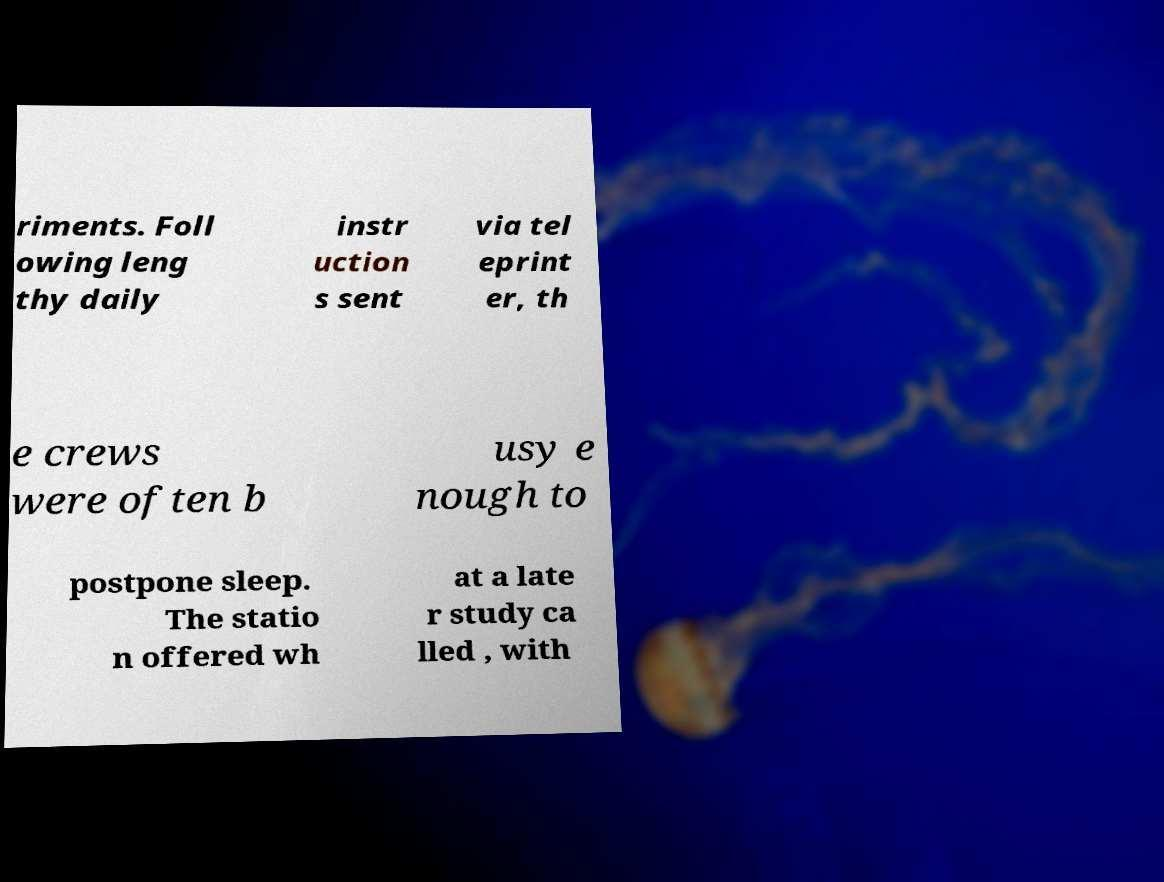For documentation purposes, I need the text within this image transcribed. Could you provide that? riments. Foll owing leng thy daily instr uction s sent via tel eprint er, th e crews were often b usy e nough to postpone sleep. The statio n offered wh at a late r study ca lled , with 